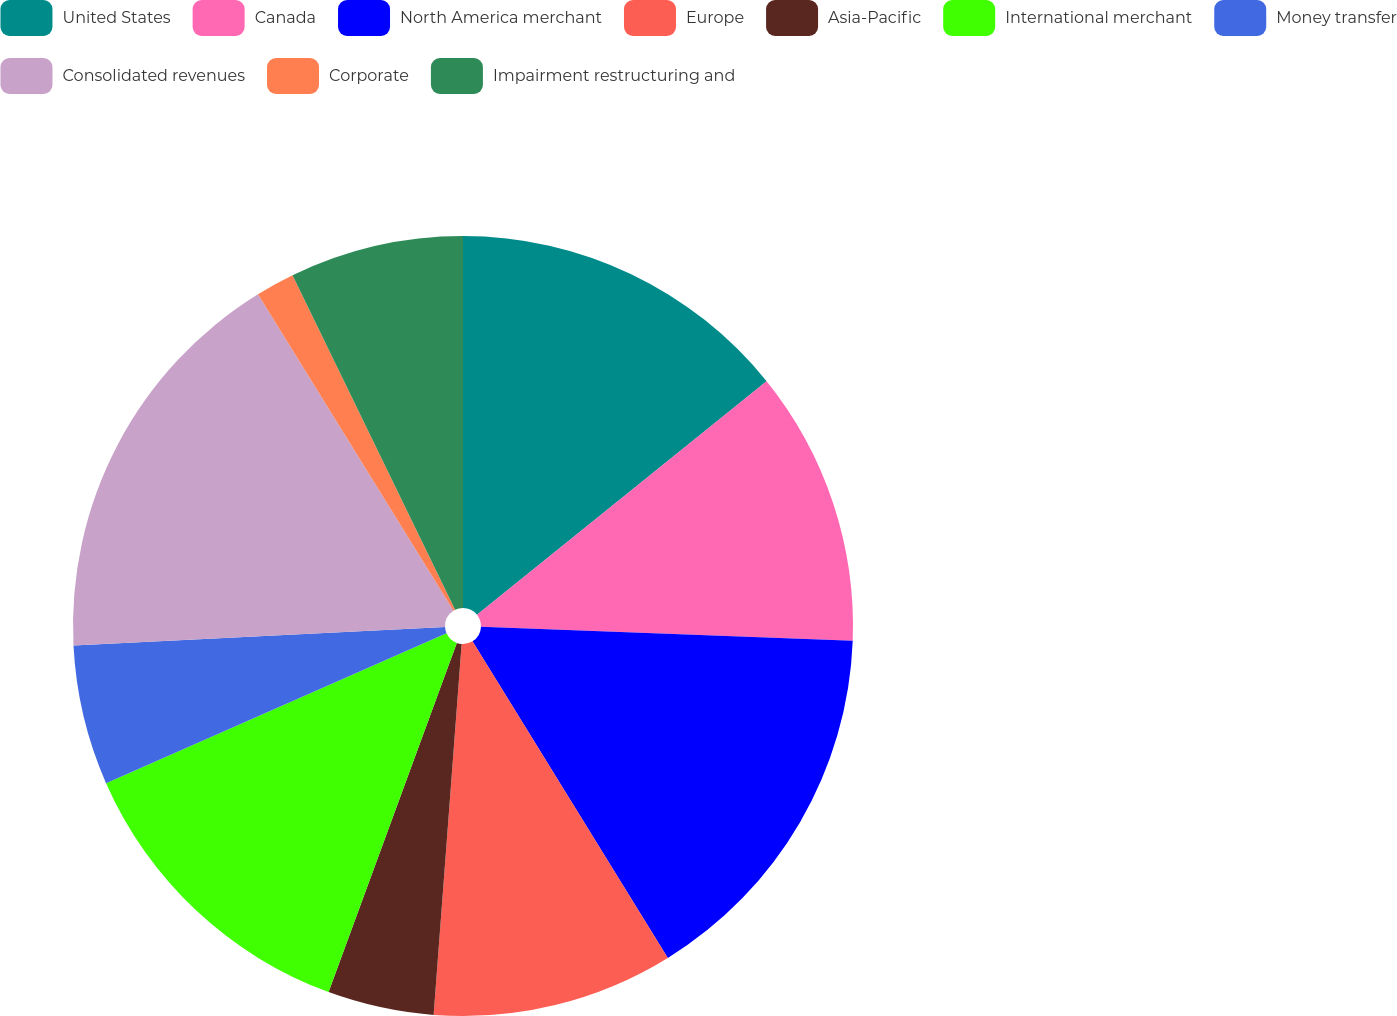Convert chart. <chart><loc_0><loc_0><loc_500><loc_500><pie_chart><fcel>United States<fcel>Canada<fcel>North America merchant<fcel>Europe<fcel>Asia-Pacific<fcel>International merchant<fcel>Money transfer<fcel>Consolidated revenues<fcel>Corporate<fcel>Impairment restructuring and<nl><fcel>14.2%<fcel>11.4%<fcel>15.6%<fcel>10.0%<fcel>4.4%<fcel>12.8%<fcel>5.8%<fcel>16.99%<fcel>1.61%<fcel>7.2%<nl></chart> 